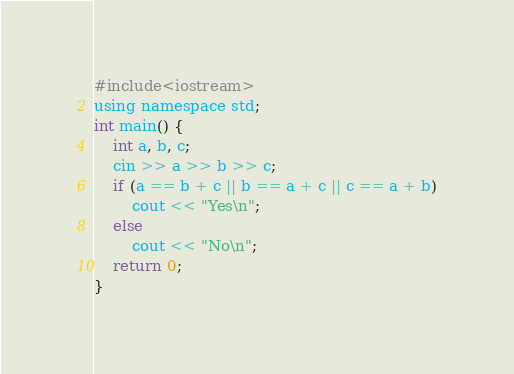<code> <loc_0><loc_0><loc_500><loc_500><_Awk_>#include<iostream>
using namespace std;
int main() {
	int a, b, c;
	cin >> a >> b >> c;
	if (a == b + c || b == a + c || c == a + b)
		cout << "Yes\n";
	else
		cout << "No\n";
	return 0;
}</code> 